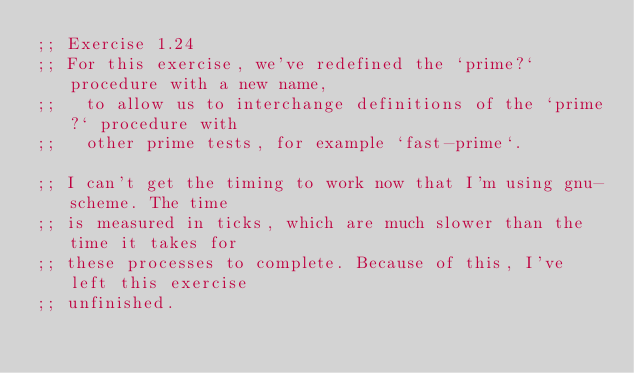Convert code to text. <code><loc_0><loc_0><loc_500><loc_500><_Scheme_>;; Exercise 1.24
;; For this exercise, we've redefined the `prime?` procedure with a new name,
;;   to allow us to interchange definitions of the `prime?` procedure with
;;   other prime tests, for example `fast-prime`.

;; I can't get the timing to work now that I'm using gnu-scheme. The time
;; is measured in ticks, which are much slower than the time it takes for
;; these processes to complete. Because of this, I've left this exercise
;; unfinished.
</code> 